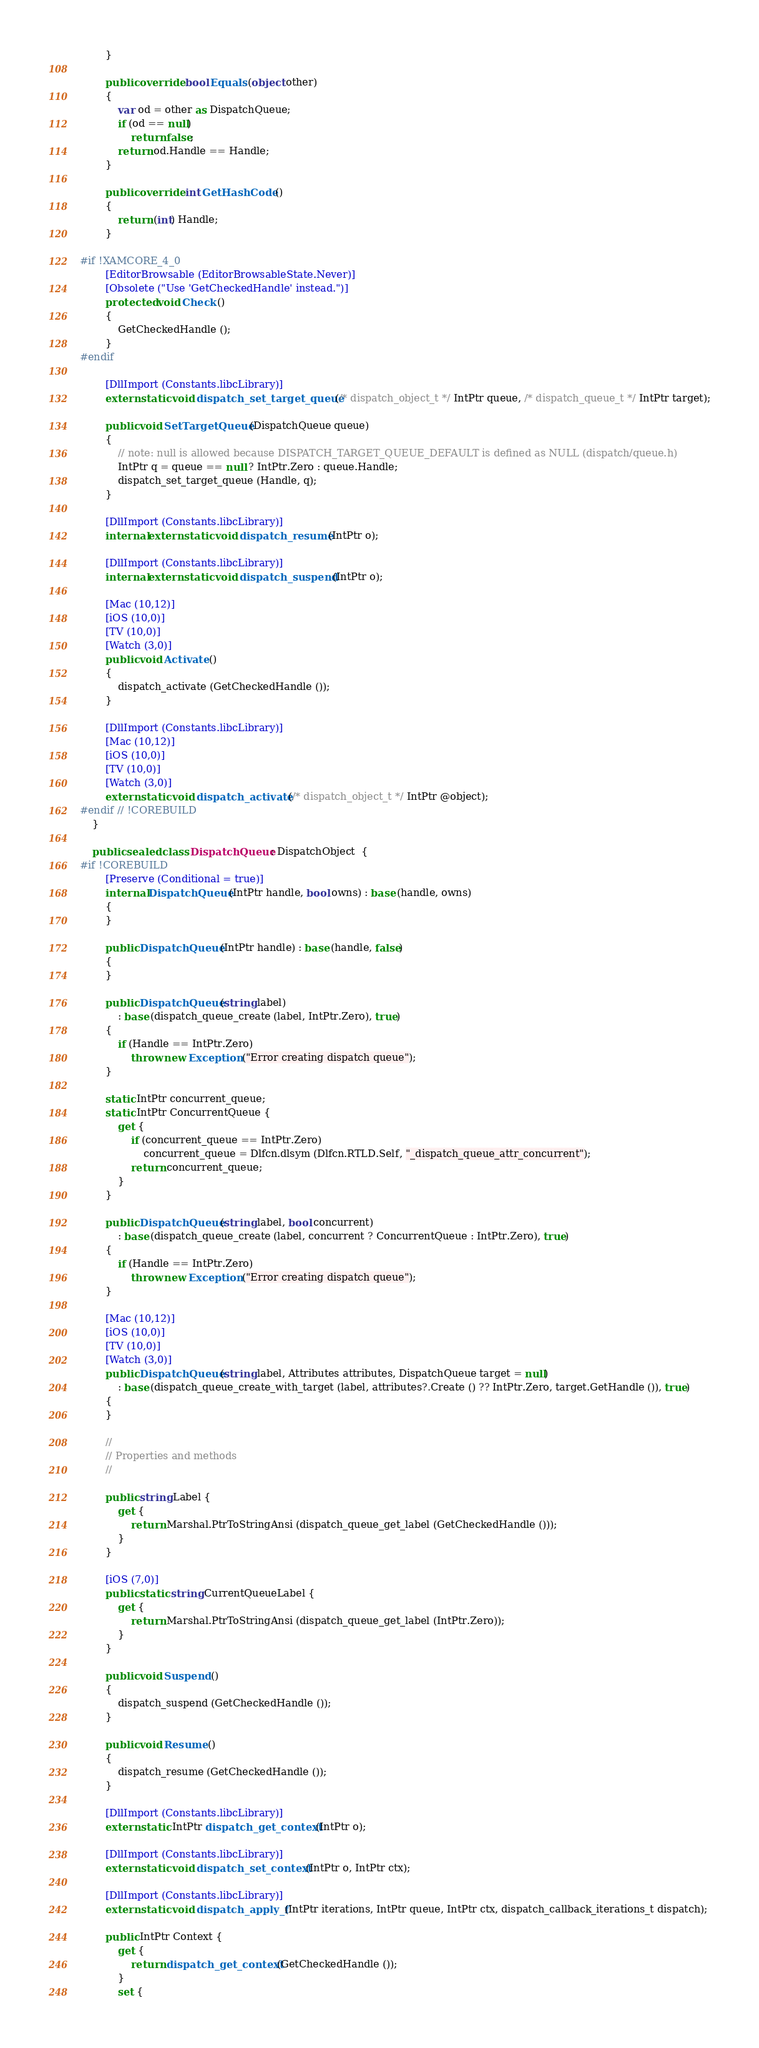<code> <loc_0><loc_0><loc_500><loc_500><_C#_>		}

		public override bool Equals (object other)
		{
			var od = other as DispatchQueue;
			if (od == null)
				return false;
			return od.Handle == Handle;
		}

		public override int GetHashCode ()
		{
			return (int) Handle;
		}

#if !XAMCORE_4_0
		[EditorBrowsable (EditorBrowsableState.Never)]
		[Obsolete ("Use 'GetCheckedHandle' instead.")]
		protected void Check ()
		{
			GetCheckedHandle ();
		}
#endif

		[DllImport (Constants.libcLibrary)]
		extern static void dispatch_set_target_queue (/* dispatch_object_t */ IntPtr queue, /* dispatch_queue_t */ IntPtr target);

		public void SetTargetQueue (DispatchQueue queue)
		{
			// note: null is allowed because DISPATCH_TARGET_QUEUE_DEFAULT is defined as NULL (dispatch/queue.h)
			IntPtr q = queue == null ? IntPtr.Zero : queue.Handle;
			dispatch_set_target_queue (Handle, q);
		}

		[DllImport (Constants.libcLibrary)]
		internal extern static void dispatch_resume (IntPtr o);

		[DllImport (Constants.libcLibrary)]
		internal extern static void dispatch_suspend (IntPtr o);

		[Mac (10,12)]
		[iOS (10,0)]
		[TV (10,0)]
		[Watch (3,0)]
		public void Activate ()
		{
			dispatch_activate (GetCheckedHandle ());
		}

		[DllImport (Constants.libcLibrary)]
		[Mac (10,12)]
		[iOS (10,0)]
		[TV (10,0)]
		[Watch (3,0)]
		extern static void dispatch_activate (/* dispatch_object_t */ IntPtr @object);
#endif // !COREBUILD
	}

	public sealed class DispatchQueue : DispatchObject  {
#if !COREBUILD
		[Preserve (Conditional = true)]
		internal DispatchQueue (IntPtr handle, bool owns) : base (handle, owns)
		{
		}

		public DispatchQueue (IntPtr handle) : base (handle, false)
		{
		}
		
		public DispatchQueue (string label)
			: base (dispatch_queue_create (label, IntPtr.Zero), true)
		{
			if (Handle == IntPtr.Zero)
				throw new Exception ("Error creating dispatch queue");
		}

		static IntPtr concurrent_queue;
		static IntPtr ConcurrentQueue {
			get {
				if (concurrent_queue == IntPtr.Zero)
					concurrent_queue = Dlfcn.dlsym (Dlfcn.RTLD.Self, "_dispatch_queue_attr_concurrent");
				return concurrent_queue;
			}
		}
		
		public DispatchQueue (string label, bool concurrent)
			: base (dispatch_queue_create (label, concurrent ? ConcurrentQueue : IntPtr.Zero), true)
		{
			if (Handle == IntPtr.Zero)
				throw new Exception ("Error creating dispatch queue");
		}
		
		[Mac (10,12)]
		[iOS (10,0)]
		[TV (10,0)]
		[Watch (3,0)]
		public DispatchQueue (string label, Attributes attributes, DispatchQueue target = null)
			: base (dispatch_queue_create_with_target (label, attributes?.Create () ?? IntPtr.Zero, target.GetHandle ()), true)
		{
		}

		//
		// Properties and methods
		//

		public string Label {
			get {
				return Marshal.PtrToStringAnsi (dispatch_queue_get_label (GetCheckedHandle ()));
			}
		}

		[iOS (7,0)]
		public static string CurrentQueueLabel {
			get {
				return Marshal.PtrToStringAnsi (dispatch_queue_get_label (IntPtr.Zero));
			}
		}

		public void Suspend ()
		{
			dispatch_suspend (GetCheckedHandle ());
		}

		public void Resume ()
		{
			dispatch_resume (GetCheckedHandle ());
		}

		[DllImport (Constants.libcLibrary)]
		extern static IntPtr dispatch_get_context (IntPtr o);

		[DllImport (Constants.libcLibrary)]
		extern static void dispatch_set_context (IntPtr o, IntPtr ctx);

		[DllImport (Constants.libcLibrary)]
		extern static void dispatch_apply_f (IntPtr iterations, IntPtr queue, IntPtr ctx, dispatch_callback_iterations_t dispatch);

		public IntPtr Context {
			get {
				return dispatch_get_context (GetCheckedHandle ());
			}
			set {</code> 